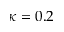<formula> <loc_0><loc_0><loc_500><loc_500>\kappa = 0 . 2</formula> 